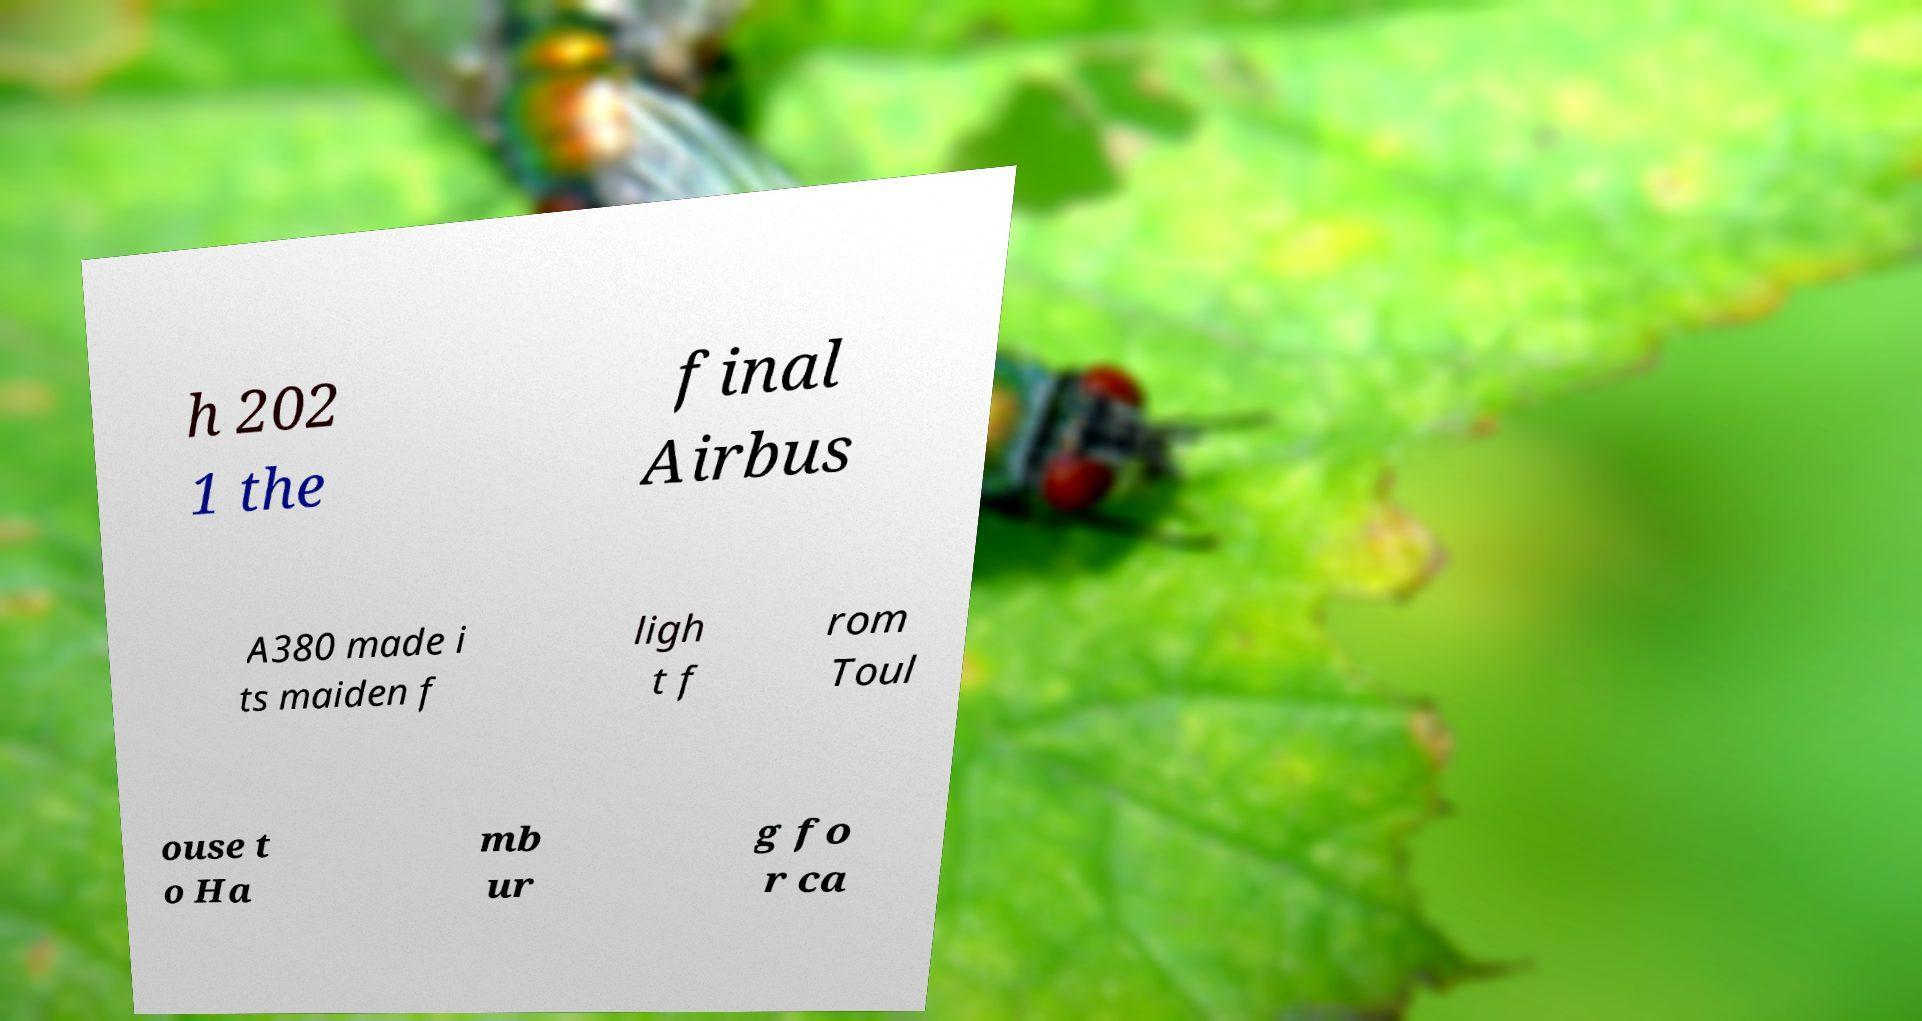Can you accurately transcribe the text from the provided image for me? h 202 1 the final Airbus A380 made i ts maiden f ligh t f rom Toul ouse t o Ha mb ur g fo r ca 